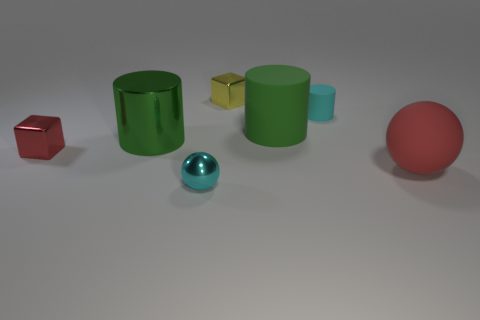Is the number of tiny yellow objects less than the number of tiny blue matte balls?
Make the answer very short. No. What is the size of the metallic object that is in front of the green shiny cylinder and right of the small red metal object?
Your response must be concise. Small. Is the red rubber thing the same size as the cyan metallic sphere?
Offer a very short reply. No. There is a cube that is to the right of the red metal block; is it the same color as the large matte cylinder?
Your answer should be very brief. No. There is a green rubber cylinder; how many matte things are to the left of it?
Offer a terse response. 0. Is the number of large brown metal spheres greater than the number of green shiny cylinders?
Provide a short and direct response. No. There is a tiny thing that is both behind the tiny metal ball and in front of the big green matte thing; what is its shape?
Offer a very short reply. Cube. Are any big green metal cubes visible?
Provide a succinct answer. No. There is another green thing that is the same shape as the green rubber object; what material is it?
Provide a succinct answer. Metal. What is the shape of the cyan object that is behind the red thing that is on the left side of the small cyan shiny sphere that is to the right of the red shiny cube?
Ensure brevity in your answer.  Cylinder. 